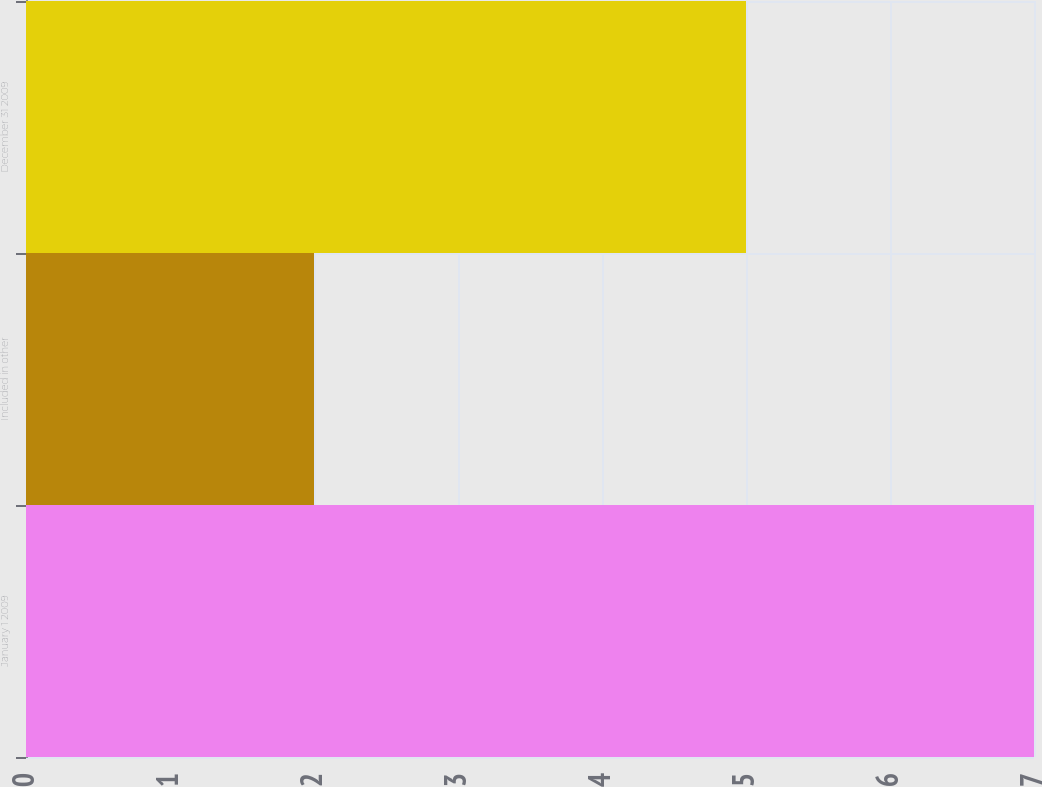Convert chart. <chart><loc_0><loc_0><loc_500><loc_500><bar_chart><fcel>January 1 2009<fcel>Included in other<fcel>December 31 2009<nl><fcel>7<fcel>2<fcel>5<nl></chart> 